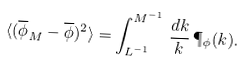<formula> <loc_0><loc_0><loc_500><loc_500>\langle ( \overline { \phi } _ { M } - \overline { \phi } ) ^ { 2 } \rangle = \int _ { L ^ { - 1 } } ^ { M ^ { - 1 } } \, \frac { d k } { k } \, \P _ { \phi } ( k ) .</formula> 